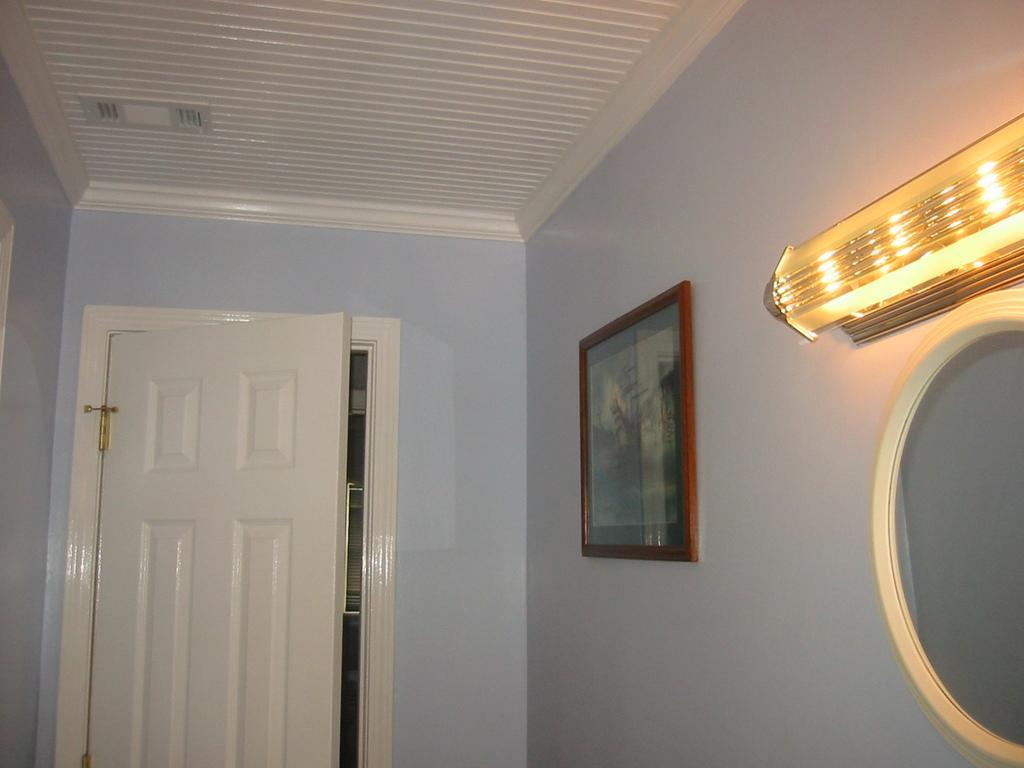Please provide a concise description of this image. In this image I can see a frame is attached to the wall. I can see mirror,light on the wall. The wall is in purple color and I can see a white door. 